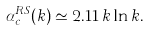<formula> <loc_0><loc_0><loc_500><loc_500>\alpha _ { c } ^ { R S } ( k ) \simeq 2 . 1 1 \, k \ln k .</formula> 